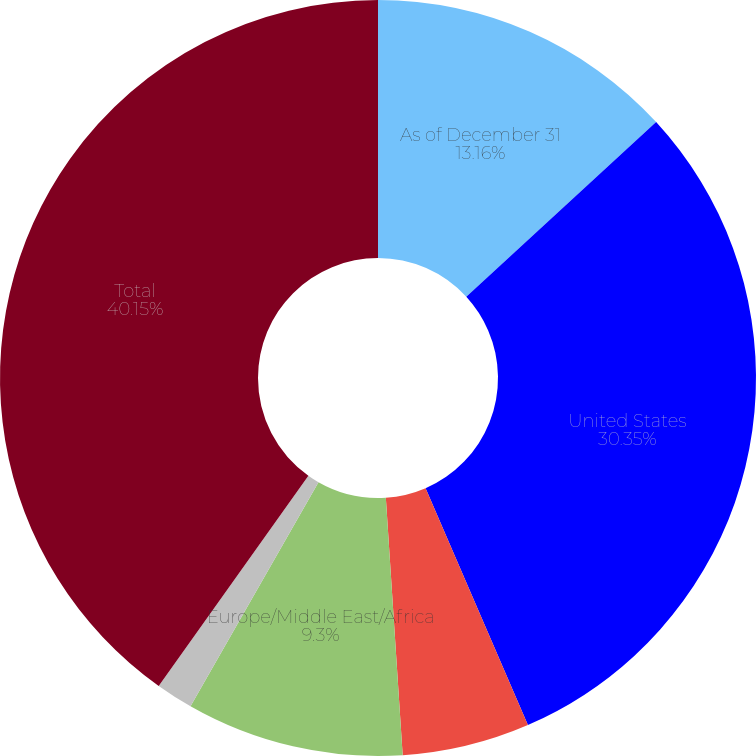Convert chart. <chart><loc_0><loc_0><loc_500><loc_500><pie_chart><fcel>As of December 31<fcel>United States<fcel>Other Americas<fcel>Europe/Middle East/Africa<fcel>Asia/Pacific<fcel>Total<nl><fcel>13.16%<fcel>30.35%<fcel>5.45%<fcel>9.3%<fcel>1.59%<fcel>40.15%<nl></chart> 